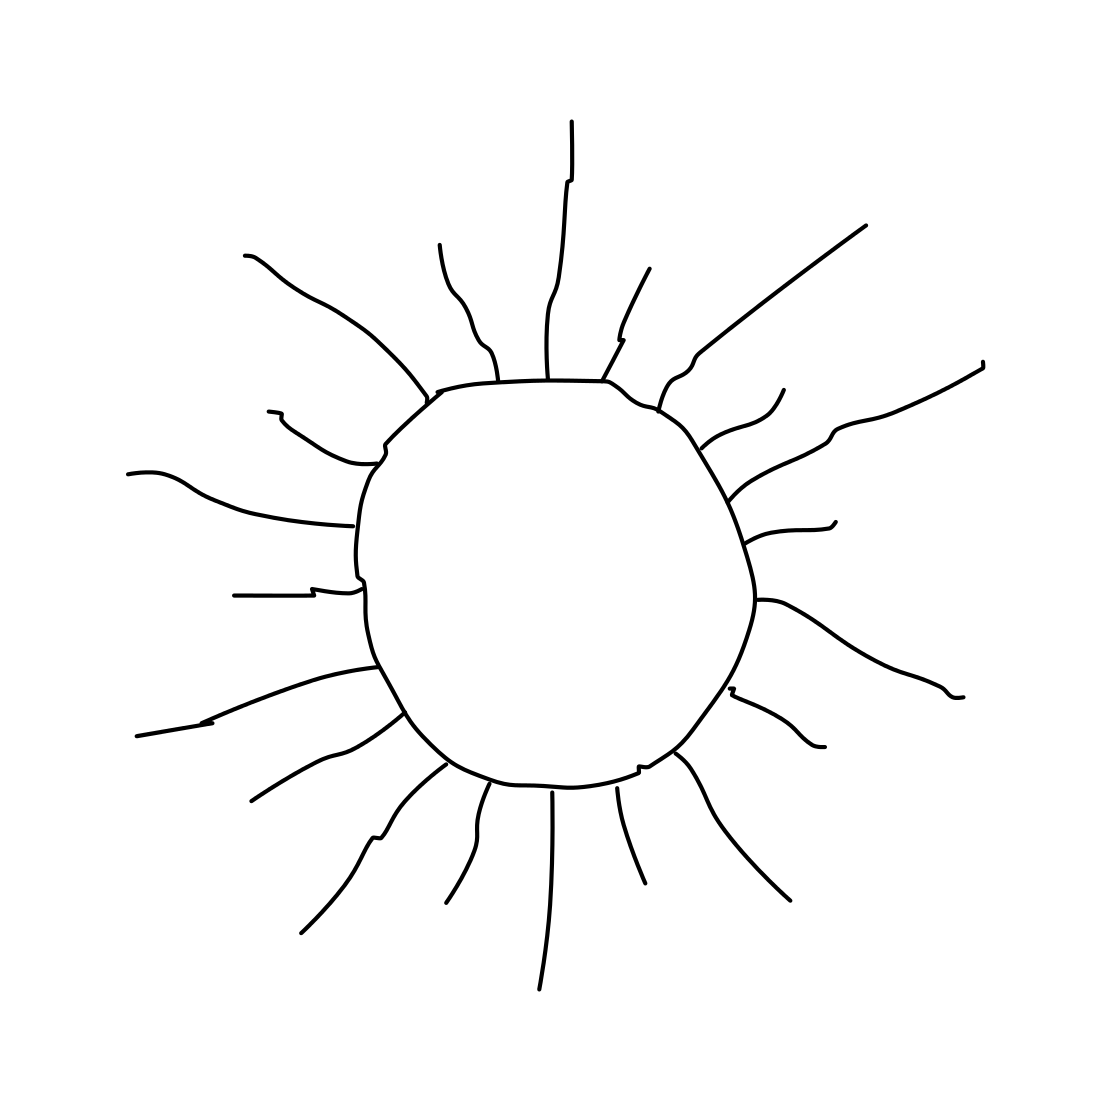If this sun were part of a story, what role might it play? In a narrative context, this sun could symbolize a beacon of hope or a new beginning, often playing a pivotal role in signaling turning points or moments of revelation for characters. 